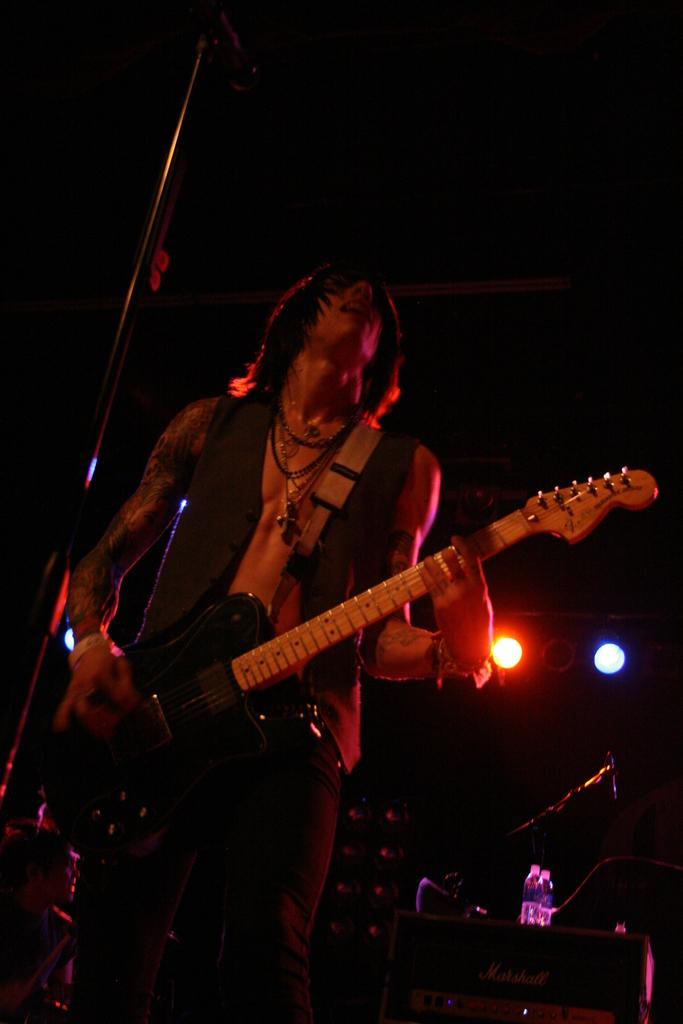What is the main subject of the image? There is a person in the image. Can you describe the person's appearance? The person has short hair. What is the person holding in the image? The person is holding a guitar. What is the person standing in front of? The person is standing in front of a microphone. What other objects can be seen in the image? There are speakers, bottles, and lights visible in the image. What type of cloth is draped over the airplane in the image? There is no airplane present in the image, so there is no cloth draped over it. 